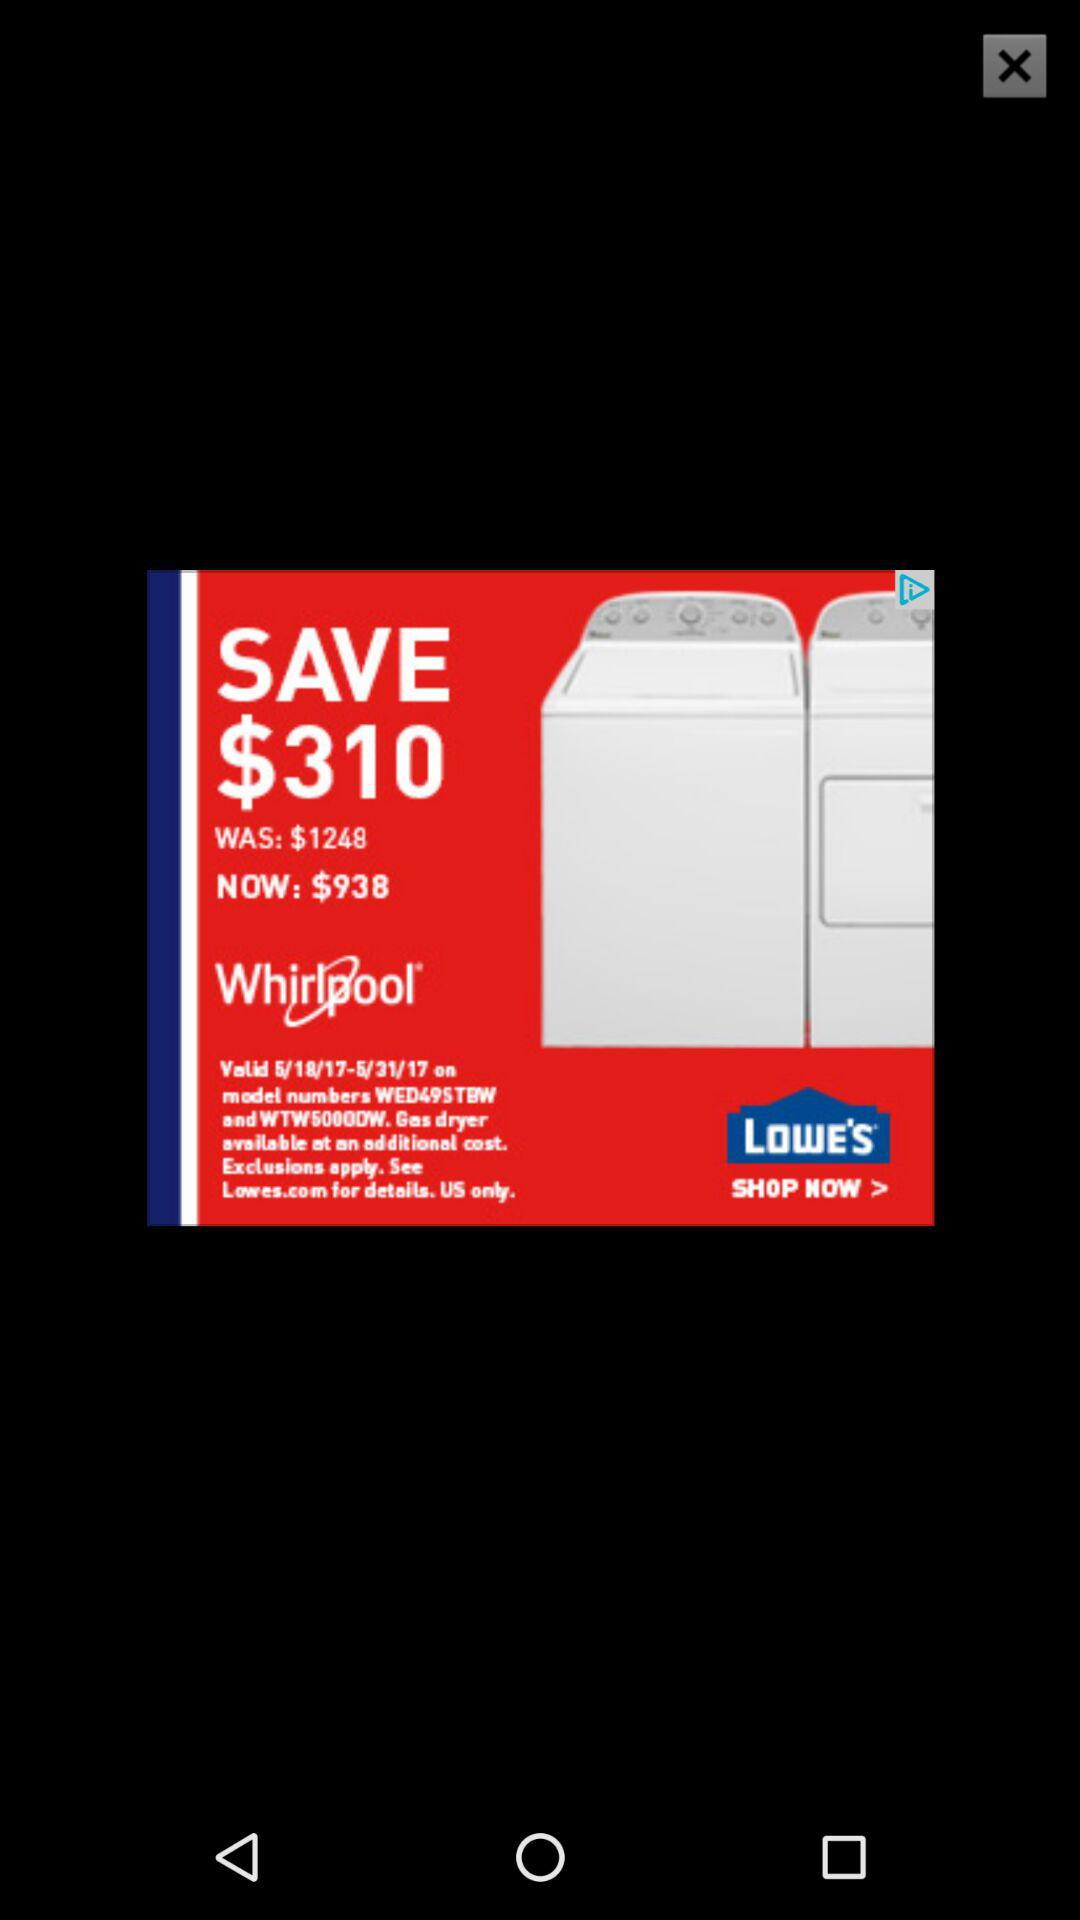How much do I save by purchasing this product?
Answer the question using a single word or phrase. $310 